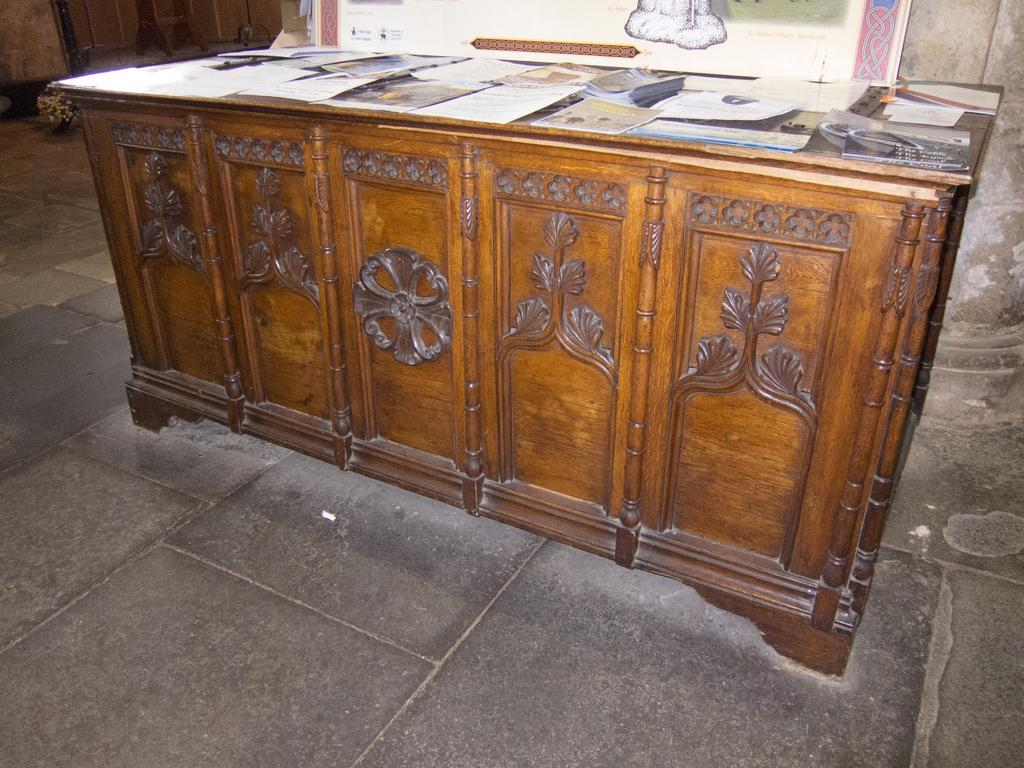What is the main object in the center of the image? There is a table in the center of the image. What items can be seen on the table? Papers and books are on the table, along with other objects. What can be seen in the background of the image? There is a wall and a banner in the background of the image. Can you see any wishes being granted in the image? There is no mention of wishes or any related activity in the image. Is there an airplane visible on the ground in the image? There is no airplane or ground visible in the image; it primarily features a table with items on it and a background with a wall and a banner. 